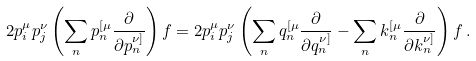<formula> <loc_0><loc_0><loc_500><loc_500>2 p _ { i } ^ { \mu } p _ { j } ^ { \nu } \left ( \sum _ { n } p _ { n } ^ { [ \mu } \frac { \partial } { \partial p _ { n } ^ { \nu ] } } \right ) f = 2 p _ { i } ^ { \mu } p _ { j } ^ { \nu } \left ( \sum _ { n } q _ { n } ^ { [ \mu } \frac { \partial } { \partial q _ { n } ^ { \nu ] } } - \sum _ { n } k _ { n } ^ { [ \mu } \frac { \partial } { \partial k _ { n } ^ { \nu ] } } \right ) f \, .</formula> 